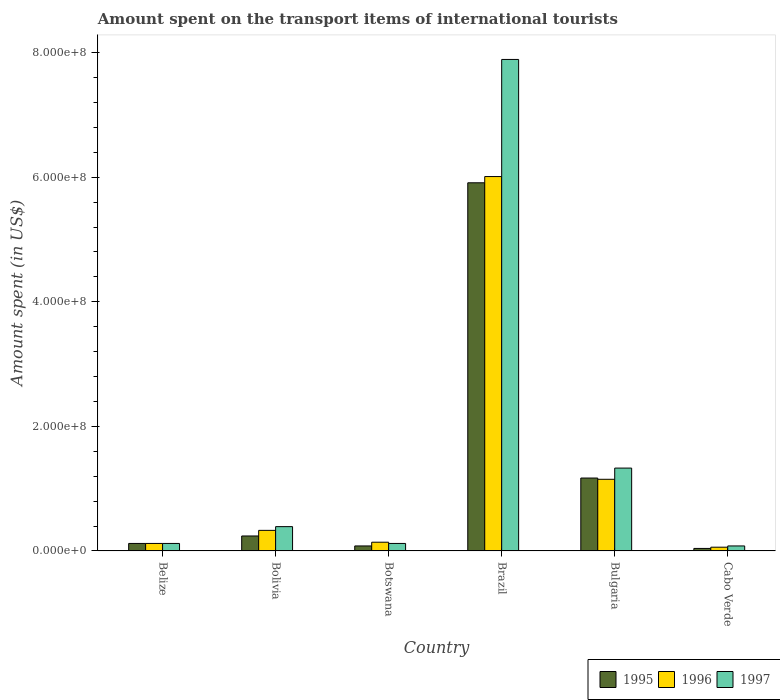In how many cases, is the number of bars for a given country not equal to the number of legend labels?
Keep it short and to the point. 0. What is the amount spent on the transport items of international tourists in 1995 in Botswana?
Ensure brevity in your answer.  8.00e+06. Across all countries, what is the maximum amount spent on the transport items of international tourists in 1995?
Give a very brief answer. 5.91e+08. Across all countries, what is the minimum amount spent on the transport items of international tourists in 1996?
Your answer should be compact. 6.00e+06. In which country was the amount spent on the transport items of international tourists in 1996 minimum?
Provide a succinct answer. Cabo Verde. What is the total amount spent on the transport items of international tourists in 1995 in the graph?
Make the answer very short. 7.56e+08. What is the difference between the amount spent on the transport items of international tourists in 1995 in Botswana and that in Brazil?
Your response must be concise. -5.83e+08. What is the difference between the amount spent on the transport items of international tourists in 1996 in Brazil and the amount spent on the transport items of international tourists in 1997 in Belize?
Your answer should be compact. 5.89e+08. What is the average amount spent on the transport items of international tourists in 1996 per country?
Offer a terse response. 1.30e+08. What is the difference between the amount spent on the transport items of international tourists of/in 1995 and amount spent on the transport items of international tourists of/in 1996 in Bolivia?
Offer a terse response. -9.00e+06. What is the ratio of the amount spent on the transport items of international tourists in 1997 in Belize to that in Botswana?
Your response must be concise. 1. Is the difference between the amount spent on the transport items of international tourists in 1995 in Bolivia and Brazil greater than the difference between the amount spent on the transport items of international tourists in 1996 in Bolivia and Brazil?
Provide a succinct answer. Yes. What is the difference between the highest and the second highest amount spent on the transport items of international tourists in 1997?
Offer a terse response. 6.56e+08. What is the difference between the highest and the lowest amount spent on the transport items of international tourists in 1996?
Make the answer very short. 5.95e+08. Is it the case that in every country, the sum of the amount spent on the transport items of international tourists in 1996 and amount spent on the transport items of international tourists in 1997 is greater than the amount spent on the transport items of international tourists in 1995?
Your answer should be compact. Yes. How many bars are there?
Provide a succinct answer. 18. Are all the bars in the graph horizontal?
Offer a very short reply. No. How many countries are there in the graph?
Give a very brief answer. 6. What is the difference between two consecutive major ticks on the Y-axis?
Your answer should be compact. 2.00e+08. Are the values on the major ticks of Y-axis written in scientific E-notation?
Your answer should be compact. Yes. Does the graph contain any zero values?
Offer a terse response. No. Does the graph contain grids?
Your response must be concise. No. Where does the legend appear in the graph?
Your answer should be very brief. Bottom right. How are the legend labels stacked?
Give a very brief answer. Horizontal. What is the title of the graph?
Your response must be concise. Amount spent on the transport items of international tourists. Does "1985" appear as one of the legend labels in the graph?
Provide a short and direct response. No. What is the label or title of the X-axis?
Provide a succinct answer. Country. What is the label or title of the Y-axis?
Your response must be concise. Amount spent (in US$). What is the Amount spent (in US$) in 1996 in Belize?
Your answer should be compact. 1.20e+07. What is the Amount spent (in US$) of 1997 in Belize?
Make the answer very short. 1.20e+07. What is the Amount spent (in US$) of 1995 in Bolivia?
Provide a succinct answer. 2.40e+07. What is the Amount spent (in US$) in 1996 in Bolivia?
Your answer should be very brief. 3.30e+07. What is the Amount spent (in US$) in 1997 in Bolivia?
Your response must be concise. 3.90e+07. What is the Amount spent (in US$) in 1995 in Botswana?
Keep it short and to the point. 8.00e+06. What is the Amount spent (in US$) in 1996 in Botswana?
Provide a succinct answer. 1.40e+07. What is the Amount spent (in US$) of 1997 in Botswana?
Offer a very short reply. 1.20e+07. What is the Amount spent (in US$) in 1995 in Brazil?
Make the answer very short. 5.91e+08. What is the Amount spent (in US$) in 1996 in Brazil?
Your answer should be compact. 6.01e+08. What is the Amount spent (in US$) in 1997 in Brazil?
Make the answer very short. 7.89e+08. What is the Amount spent (in US$) of 1995 in Bulgaria?
Your answer should be compact. 1.17e+08. What is the Amount spent (in US$) of 1996 in Bulgaria?
Offer a terse response. 1.15e+08. What is the Amount spent (in US$) in 1997 in Bulgaria?
Give a very brief answer. 1.33e+08. What is the Amount spent (in US$) in 1997 in Cabo Verde?
Offer a very short reply. 8.00e+06. Across all countries, what is the maximum Amount spent (in US$) of 1995?
Provide a short and direct response. 5.91e+08. Across all countries, what is the maximum Amount spent (in US$) in 1996?
Offer a terse response. 6.01e+08. Across all countries, what is the maximum Amount spent (in US$) of 1997?
Make the answer very short. 7.89e+08. Across all countries, what is the minimum Amount spent (in US$) of 1996?
Ensure brevity in your answer.  6.00e+06. What is the total Amount spent (in US$) of 1995 in the graph?
Give a very brief answer. 7.56e+08. What is the total Amount spent (in US$) in 1996 in the graph?
Your answer should be very brief. 7.81e+08. What is the total Amount spent (in US$) of 1997 in the graph?
Offer a terse response. 9.93e+08. What is the difference between the Amount spent (in US$) in 1995 in Belize and that in Bolivia?
Offer a terse response. -1.20e+07. What is the difference between the Amount spent (in US$) in 1996 in Belize and that in Bolivia?
Offer a very short reply. -2.10e+07. What is the difference between the Amount spent (in US$) in 1997 in Belize and that in Bolivia?
Your response must be concise. -2.70e+07. What is the difference between the Amount spent (in US$) of 1996 in Belize and that in Botswana?
Give a very brief answer. -2.00e+06. What is the difference between the Amount spent (in US$) of 1995 in Belize and that in Brazil?
Provide a succinct answer. -5.79e+08. What is the difference between the Amount spent (in US$) in 1996 in Belize and that in Brazil?
Offer a very short reply. -5.89e+08. What is the difference between the Amount spent (in US$) of 1997 in Belize and that in Brazil?
Give a very brief answer. -7.77e+08. What is the difference between the Amount spent (in US$) in 1995 in Belize and that in Bulgaria?
Ensure brevity in your answer.  -1.05e+08. What is the difference between the Amount spent (in US$) in 1996 in Belize and that in Bulgaria?
Offer a very short reply. -1.03e+08. What is the difference between the Amount spent (in US$) in 1997 in Belize and that in Bulgaria?
Your response must be concise. -1.21e+08. What is the difference between the Amount spent (in US$) of 1996 in Belize and that in Cabo Verde?
Your answer should be very brief. 6.00e+06. What is the difference between the Amount spent (in US$) in 1997 in Belize and that in Cabo Verde?
Your answer should be compact. 4.00e+06. What is the difference between the Amount spent (in US$) of 1995 in Bolivia and that in Botswana?
Give a very brief answer. 1.60e+07. What is the difference between the Amount spent (in US$) in 1996 in Bolivia and that in Botswana?
Give a very brief answer. 1.90e+07. What is the difference between the Amount spent (in US$) of 1997 in Bolivia and that in Botswana?
Your response must be concise. 2.70e+07. What is the difference between the Amount spent (in US$) of 1995 in Bolivia and that in Brazil?
Offer a terse response. -5.67e+08. What is the difference between the Amount spent (in US$) of 1996 in Bolivia and that in Brazil?
Keep it short and to the point. -5.68e+08. What is the difference between the Amount spent (in US$) of 1997 in Bolivia and that in Brazil?
Offer a very short reply. -7.50e+08. What is the difference between the Amount spent (in US$) of 1995 in Bolivia and that in Bulgaria?
Your response must be concise. -9.30e+07. What is the difference between the Amount spent (in US$) in 1996 in Bolivia and that in Bulgaria?
Your answer should be very brief. -8.20e+07. What is the difference between the Amount spent (in US$) of 1997 in Bolivia and that in Bulgaria?
Your response must be concise. -9.40e+07. What is the difference between the Amount spent (in US$) in 1996 in Bolivia and that in Cabo Verde?
Provide a succinct answer. 2.70e+07. What is the difference between the Amount spent (in US$) in 1997 in Bolivia and that in Cabo Verde?
Your answer should be compact. 3.10e+07. What is the difference between the Amount spent (in US$) of 1995 in Botswana and that in Brazil?
Offer a terse response. -5.83e+08. What is the difference between the Amount spent (in US$) in 1996 in Botswana and that in Brazil?
Your response must be concise. -5.87e+08. What is the difference between the Amount spent (in US$) in 1997 in Botswana and that in Brazil?
Offer a terse response. -7.77e+08. What is the difference between the Amount spent (in US$) of 1995 in Botswana and that in Bulgaria?
Make the answer very short. -1.09e+08. What is the difference between the Amount spent (in US$) of 1996 in Botswana and that in Bulgaria?
Provide a short and direct response. -1.01e+08. What is the difference between the Amount spent (in US$) in 1997 in Botswana and that in Bulgaria?
Offer a terse response. -1.21e+08. What is the difference between the Amount spent (in US$) in 1995 in Botswana and that in Cabo Verde?
Offer a very short reply. 4.00e+06. What is the difference between the Amount spent (in US$) of 1995 in Brazil and that in Bulgaria?
Keep it short and to the point. 4.74e+08. What is the difference between the Amount spent (in US$) of 1996 in Brazil and that in Bulgaria?
Offer a very short reply. 4.86e+08. What is the difference between the Amount spent (in US$) in 1997 in Brazil and that in Bulgaria?
Make the answer very short. 6.56e+08. What is the difference between the Amount spent (in US$) of 1995 in Brazil and that in Cabo Verde?
Your answer should be very brief. 5.87e+08. What is the difference between the Amount spent (in US$) in 1996 in Brazil and that in Cabo Verde?
Keep it short and to the point. 5.95e+08. What is the difference between the Amount spent (in US$) in 1997 in Brazil and that in Cabo Verde?
Your answer should be very brief. 7.81e+08. What is the difference between the Amount spent (in US$) of 1995 in Bulgaria and that in Cabo Verde?
Make the answer very short. 1.13e+08. What is the difference between the Amount spent (in US$) of 1996 in Bulgaria and that in Cabo Verde?
Provide a short and direct response. 1.09e+08. What is the difference between the Amount spent (in US$) in 1997 in Bulgaria and that in Cabo Verde?
Provide a short and direct response. 1.25e+08. What is the difference between the Amount spent (in US$) of 1995 in Belize and the Amount spent (in US$) of 1996 in Bolivia?
Ensure brevity in your answer.  -2.10e+07. What is the difference between the Amount spent (in US$) of 1995 in Belize and the Amount spent (in US$) of 1997 in Bolivia?
Your response must be concise. -2.70e+07. What is the difference between the Amount spent (in US$) of 1996 in Belize and the Amount spent (in US$) of 1997 in Bolivia?
Give a very brief answer. -2.70e+07. What is the difference between the Amount spent (in US$) in 1995 in Belize and the Amount spent (in US$) in 1997 in Botswana?
Your answer should be compact. 0. What is the difference between the Amount spent (in US$) in 1996 in Belize and the Amount spent (in US$) in 1997 in Botswana?
Offer a very short reply. 0. What is the difference between the Amount spent (in US$) in 1995 in Belize and the Amount spent (in US$) in 1996 in Brazil?
Make the answer very short. -5.89e+08. What is the difference between the Amount spent (in US$) of 1995 in Belize and the Amount spent (in US$) of 1997 in Brazil?
Keep it short and to the point. -7.77e+08. What is the difference between the Amount spent (in US$) in 1996 in Belize and the Amount spent (in US$) in 1997 in Brazil?
Provide a short and direct response. -7.77e+08. What is the difference between the Amount spent (in US$) in 1995 in Belize and the Amount spent (in US$) in 1996 in Bulgaria?
Keep it short and to the point. -1.03e+08. What is the difference between the Amount spent (in US$) in 1995 in Belize and the Amount spent (in US$) in 1997 in Bulgaria?
Ensure brevity in your answer.  -1.21e+08. What is the difference between the Amount spent (in US$) of 1996 in Belize and the Amount spent (in US$) of 1997 in Bulgaria?
Your response must be concise. -1.21e+08. What is the difference between the Amount spent (in US$) of 1995 in Belize and the Amount spent (in US$) of 1996 in Cabo Verde?
Your answer should be compact. 6.00e+06. What is the difference between the Amount spent (in US$) of 1995 in Belize and the Amount spent (in US$) of 1997 in Cabo Verde?
Your response must be concise. 4.00e+06. What is the difference between the Amount spent (in US$) of 1995 in Bolivia and the Amount spent (in US$) of 1997 in Botswana?
Your response must be concise. 1.20e+07. What is the difference between the Amount spent (in US$) in 1996 in Bolivia and the Amount spent (in US$) in 1997 in Botswana?
Keep it short and to the point. 2.10e+07. What is the difference between the Amount spent (in US$) in 1995 in Bolivia and the Amount spent (in US$) in 1996 in Brazil?
Ensure brevity in your answer.  -5.77e+08. What is the difference between the Amount spent (in US$) in 1995 in Bolivia and the Amount spent (in US$) in 1997 in Brazil?
Provide a short and direct response. -7.65e+08. What is the difference between the Amount spent (in US$) of 1996 in Bolivia and the Amount spent (in US$) of 1997 in Brazil?
Ensure brevity in your answer.  -7.56e+08. What is the difference between the Amount spent (in US$) of 1995 in Bolivia and the Amount spent (in US$) of 1996 in Bulgaria?
Your answer should be compact. -9.10e+07. What is the difference between the Amount spent (in US$) of 1995 in Bolivia and the Amount spent (in US$) of 1997 in Bulgaria?
Make the answer very short. -1.09e+08. What is the difference between the Amount spent (in US$) of 1996 in Bolivia and the Amount spent (in US$) of 1997 in Bulgaria?
Provide a short and direct response. -1.00e+08. What is the difference between the Amount spent (in US$) in 1995 in Bolivia and the Amount spent (in US$) in 1996 in Cabo Verde?
Your answer should be compact. 1.80e+07. What is the difference between the Amount spent (in US$) of 1995 in Bolivia and the Amount spent (in US$) of 1997 in Cabo Verde?
Keep it short and to the point. 1.60e+07. What is the difference between the Amount spent (in US$) of 1996 in Bolivia and the Amount spent (in US$) of 1997 in Cabo Verde?
Your answer should be very brief. 2.50e+07. What is the difference between the Amount spent (in US$) in 1995 in Botswana and the Amount spent (in US$) in 1996 in Brazil?
Ensure brevity in your answer.  -5.93e+08. What is the difference between the Amount spent (in US$) of 1995 in Botswana and the Amount spent (in US$) of 1997 in Brazil?
Give a very brief answer. -7.81e+08. What is the difference between the Amount spent (in US$) in 1996 in Botswana and the Amount spent (in US$) in 1997 in Brazil?
Your answer should be very brief. -7.75e+08. What is the difference between the Amount spent (in US$) in 1995 in Botswana and the Amount spent (in US$) in 1996 in Bulgaria?
Offer a terse response. -1.07e+08. What is the difference between the Amount spent (in US$) of 1995 in Botswana and the Amount spent (in US$) of 1997 in Bulgaria?
Provide a short and direct response. -1.25e+08. What is the difference between the Amount spent (in US$) in 1996 in Botswana and the Amount spent (in US$) in 1997 in Bulgaria?
Your answer should be very brief. -1.19e+08. What is the difference between the Amount spent (in US$) of 1995 in Botswana and the Amount spent (in US$) of 1997 in Cabo Verde?
Offer a terse response. 0. What is the difference between the Amount spent (in US$) of 1996 in Botswana and the Amount spent (in US$) of 1997 in Cabo Verde?
Your response must be concise. 6.00e+06. What is the difference between the Amount spent (in US$) in 1995 in Brazil and the Amount spent (in US$) in 1996 in Bulgaria?
Provide a short and direct response. 4.76e+08. What is the difference between the Amount spent (in US$) in 1995 in Brazil and the Amount spent (in US$) in 1997 in Bulgaria?
Keep it short and to the point. 4.58e+08. What is the difference between the Amount spent (in US$) in 1996 in Brazil and the Amount spent (in US$) in 1997 in Bulgaria?
Offer a terse response. 4.68e+08. What is the difference between the Amount spent (in US$) of 1995 in Brazil and the Amount spent (in US$) of 1996 in Cabo Verde?
Provide a succinct answer. 5.85e+08. What is the difference between the Amount spent (in US$) of 1995 in Brazil and the Amount spent (in US$) of 1997 in Cabo Verde?
Ensure brevity in your answer.  5.83e+08. What is the difference between the Amount spent (in US$) in 1996 in Brazil and the Amount spent (in US$) in 1997 in Cabo Verde?
Keep it short and to the point. 5.93e+08. What is the difference between the Amount spent (in US$) of 1995 in Bulgaria and the Amount spent (in US$) of 1996 in Cabo Verde?
Offer a terse response. 1.11e+08. What is the difference between the Amount spent (in US$) in 1995 in Bulgaria and the Amount spent (in US$) in 1997 in Cabo Verde?
Offer a very short reply. 1.09e+08. What is the difference between the Amount spent (in US$) of 1996 in Bulgaria and the Amount spent (in US$) of 1997 in Cabo Verde?
Offer a very short reply. 1.07e+08. What is the average Amount spent (in US$) of 1995 per country?
Keep it short and to the point. 1.26e+08. What is the average Amount spent (in US$) of 1996 per country?
Make the answer very short. 1.30e+08. What is the average Amount spent (in US$) of 1997 per country?
Make the answer very short. 1.66e+08. What is the difference between the Amount spent (in US$) of 1995 and Amount spent (in US$) of 1996 in Belize?
Provide a short and direct response. 0. What is the difference between the Amount spent (in US$) of 1995 and Amount spent (in US$) of 1997 in Belize?
Ensure brevity in your answer.  0. What is the difference between the Amount spent (in US$) in 1995 and Amount spent (in US$) in 1996 in Bolivia?
Give a very brief answer. -9.00e+06. What is the difference between the Amount spent (in US$) of 1995 and Amount spent (in US$) of 1997 in Bolivia?
Ensure brevity in your answer.  -1.50e+07. What is the difference between the Amount spent (in US$) of 1996 and Amount spent (in US$) of 1997 in Bolivia?
Make the answer very short. -6.00e+06. What is the difference between the Amount spent (in US$) in 1995 and Amount spent (in US$) in 1996 in Botswana?
Provide a succinct answer. -6.00e+06. What is the difference between the Amount spent (in US$) of 1995 and Amount spent (in US$) of 1996 in Brazil?
Make the answer very short. -1.00e+07. What is the difference between the Amount spent (in US$) in 1995 and Amount spent (in US$) in 1997 in Brazil?
Provide a short and direct response. -1.98e+08. What is the difference between the Amount spent (in US$) in 1996 and Amount spent (in US$) in 1997 in Brazil?
Your response must be concise. -1.88e+08. What is the difference between the Amount spent (in US$) in 1995 and Amount spent (in US$) in 1996 in Bulgaria?
Make the answer very short. 2.00e+06. What is the difference between the Amount spent (in US$) of 1995 and Amount spent (in US$) of 1997 in Bulgaria?
Keep it short and to the point. -1.60e+07. What is the difference between the Amount spent (in US$) of 1996 and Amount spent (in US$) of 1997 in Bulgaria?
Your response must be concise. -1.80e+07. What is the difference between the Amount spent (in US$) of 1995 and Amount spent (in US$) of 1997 in Cabo Verde?
Your response must be concise. -4.00e+06. What is the ratio of the Amount spent (in US$) of 1995 in Belize to that in Bolivia?
Your answer should be very brief. 0.5. What is the ratio of the Amount spent (in US$) in 1996 in Belize to that in Bolivia?
Your answer should be compact. 0.36. What is the ratio of the Amount spent (in US$) of 1997 in Belize to that in Bolivia?
Keep it short and to the point. 0.31. What is the ratio of the Amount spent (in US$) in 1997 in Belize to that in Botswana?
Make the answer very short. 1. What is the ratio of the Amount spent (in US$) in 1995 in Belize to that in Brazil?
Offer a very short reply. 0.02. What is the ratio of the Amount spent (in US$) of 1996 in Belize to that in Brazil?
Give a very brief answer. 0.02. What is the ratio of the Amount spent (in US$) in 1997 in Belize to that in Brazil?
Keep it short and to the point. 0.02. What is the ratio of the Amount spent (in US$) in 1995 in Belize to that in Bulgaria?
Your answer should be very brief. 0.1. What is the ratio of the Amount spent (in US$) in 1996 in Belize to that in Bulgaria?
Offer a very short reply. 0.1. What is the ratio of the Amount spent (in US$) of 1997 in Belize to that in Bulgaria?
Keep it short and to the point. 0.09. What is the ratio of the Amount spent (in US$) in 1997 in Belize to that in Cabo Verde?
Offer a terse response. 1.5. What is the ratio of the Amount spent (in US$) of 1995 in Bolivia to that in Botswana?
Offer a very short reply. 3. What is the ratio of the Amount spent (in US$) in 1996 in Bolivia to that in Botswana?
Offer a terse response. 2.36. What is the ratio of the Amount spent (in US$) in 1997 in Bolivia to that in Botswana?
Give a very brief answer. 3.25. What is the ratio of the Amount spent (in US$) of 1995 in Bolivia to that in Brazil?
Your answer should be very brief. 0.04. What is the ratio of the Amount spent (in US$) in 1996 in Bolivia to that in Brazil?
Ensure brevity in your answer.  0.05. What is the ratio of the Amount spent (in US$) in 1997 in Bolivia to that in Brazil?
Keep it short and to the point. 0.05. What is the ratio of the Amount spent (in US$) of 1995 in Bolivia to that in Bulgaria?
Provide a succinct answer. 0.21. What is the ratio of the Amount spent (in US$) of 1996 in Bolivia to that in Bulgaria?
Your answer should be compact. 0.29. What is the ratio of the Amount spent (in US$) in 1997 in Bolivia to that in Bulgaria?
Offer a very short reply. 0.29. What is the ratio of the Amount spent (in US$) of 1995 in Bolivia to that in Cabo Verde?
Provide a short and direct response. 6. What is the ratio of the Amount spent (in US$) in 1996 in Bolivia to that in Cabo Verde?
Offer a terse response. 5.5. What is the ratio of the Amount spent (in US$) of 1997 in Bolivia to that in Cabo Verde?
Provide a succinct answer. 4.88. What is the ratio of the Amount spent (in US$) of 1995 in Botswana to that in Brazil?
Provide a succinct answer. 0.01. What is the ratio of the Amount spent (in US$) of 1996 in Botswana to that in Brazil?
Make the answer very short. 0.02. What is the ratio of the Amount spent (in US$) in 1997 in Botswana to that in Brazil?
Ensure brevity in your answer.  0.02. What is the ratio of the Amount spent (in US$) in 1995 in Botswana to that in Bulgaria?
Ensure brevity in your answer.  0.07. What is the ratio of the Amount spent (in US$) of 1996 in Botswana to that in Bulgaria?
Offer a terse response. 0.12. What is the ratio of the Amount spent (in US$) of 1997 in Botswana to that in Bulgaria?
Make the answer very short. 0.09. What is the ratio of the Amount spent (in US$) of 1995 in Botswana to that in Cabo Verde?
Offer a terse response. 2. What is the ratio of the Amount spent (in US$) of 1996 in Botswana to that in Cabo Verde?
Your answer should be very brief. 2.33. What is the ratio of the Amount spent (in US$) of 1997 in Botswana to that in Cabo Verde?
Offer a very short reply. 1.5. What is the ratio of the Amount spent (in US$) of 1995 in Brazil to that in Bulgaria?
Your answer should be very brief. 5.05. What is the ratio of the Amount spent (in US$) of 1996 in Brazil to that in Bulgaria?
Ensure brevity in your answer.  5.23. What is the ratio of the Amount spent (in US$) of 1997 in Brazil to that in Bulgaria?
Your answer should be very brief. 5.93. What is the ratio of the Amount spent (in US$) in 1995 in Brazil to that in Cabo Verde?
Ensure brevity in your answer.  147.75. What is the ratio of the Amount spent (in US$) in 1996 in Brazil to that in Cabo Verde?
Your response must be concise. 100.17. What is the ratio of the Amount spent (in US$) in 1997 in Brazil to that in Cabo Verde?
Provide a short and direct response. 98.62. What is the ratio of the Amount spent (in US$) in 1995 in Bulgaria to that in Cabo Verde?
Offer a very short reply. 29.25. What is the ratio of the Amount spent (in US$) in 1996 in Bulgaria to that in Cabo Verde?
Ensure brevity in your answer.  19.17. What is the ratio of the Amount spent (in US$) in 1997 in Bulgaria to that in Cabo Verde?
Provide a short and direct response. 16.62. What is the difference between the highest and the second highest Amount spent (in US$) in 1995?
Ensure brevity in your answer.  4.74e+08. What is the difference between the highest and the second highest Amount spent (in US$) in 1996?
Ensure brevity in your answer.  4.86e+08. What is the difference between the highest and the second highest Amount spent (in US$) of 1997?
Your response must be concise. 6.56e+08. What is the difference between the highest and the lowest Amount spent (in US$) of 1995?
Keep it short and to the point. 5.87e+08. What is the difference between the highest and the lowest Amount spent (in US$) in 1996?
Your response must be concise. 5.95e+08. What is the difference between the highest and the lowest Amount spent (in US$) in 1997?
Provide a short and direct response. 7.81e+08. 